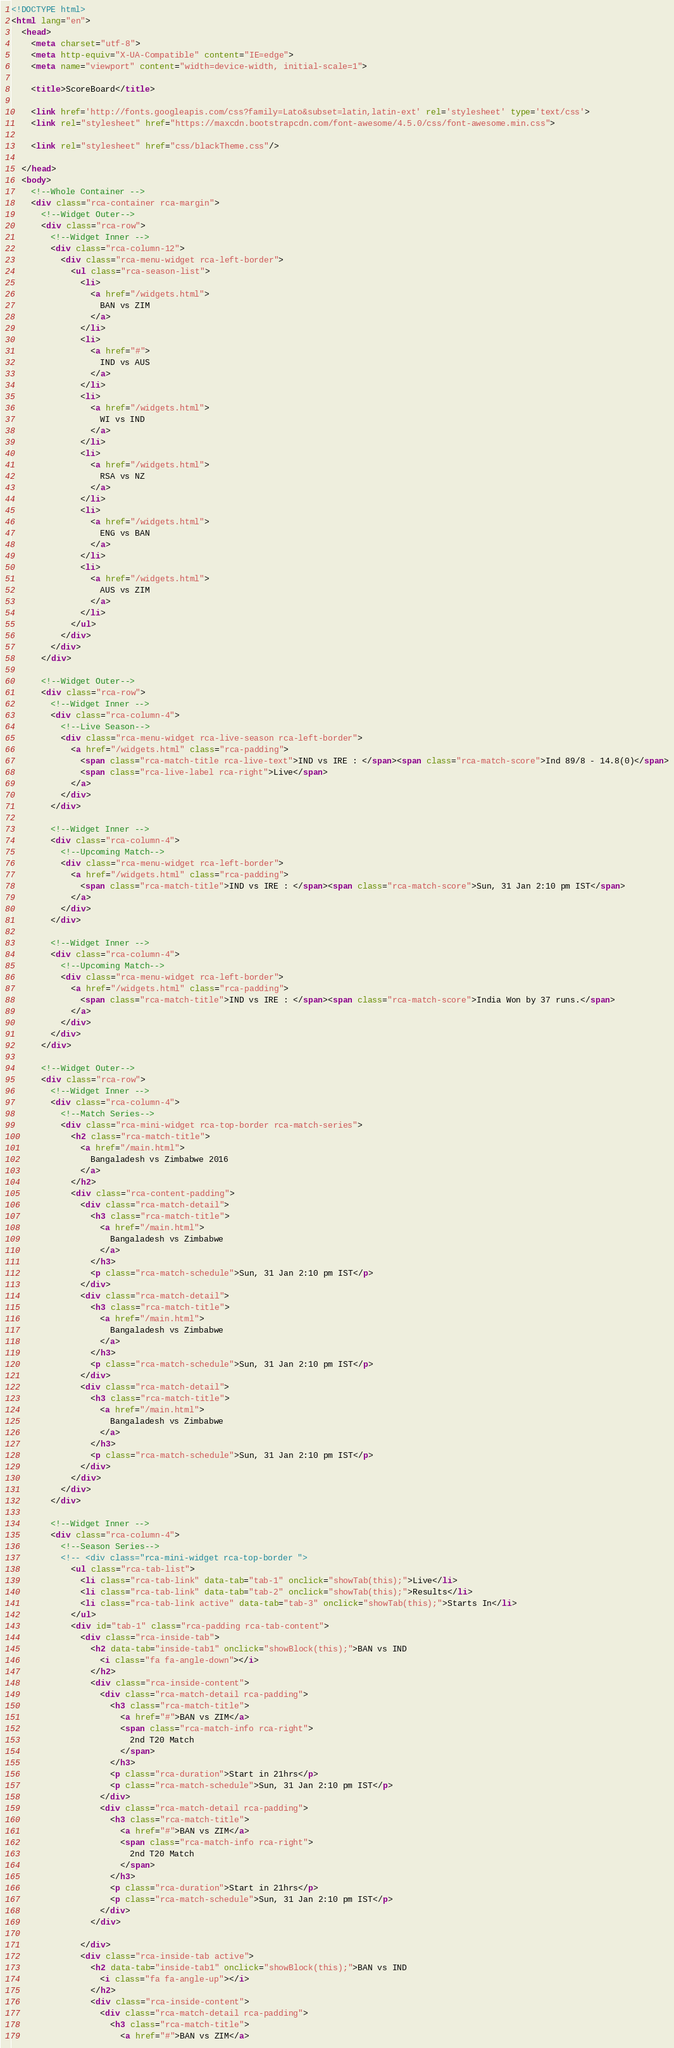<code> <loc_0><loc_0><loc_500><loc_500><_HTML_><!DOCTYPE html>
<html lang="en">
  <head>
    <meta charset="utf-8">
    <meta http-equiv="X-UA-Compatible" content="IE=edge">
    <meta name="viewport" content="width=device-width, initial-scale=1">

    <title>ScoreBoard</title>

    <link href='http://fonts.googleapis.com/css?family=Lato&subset=latin,latin-ext' rel='stylesheet' type='text/css'>
    <link rel="stylesheet" href="https://maxcdn.bootstrapcdn.com/font-awesome/4.5.0/css/font-awesome.min.css">

    <link rel="stylesheet" href="css/blackTheme.css"/>

  </head>
  <body>
    <!--Whole Container -->
    <div class="rca-container rca-margin">
      <!--Widget Outer-->
      <div class="rca-row">
        <!--Widget Inner -->
        <div class="rca-column-12">
          <div class="rca-menu-widget rca-left-border">
            <ul class="rca-season-list">
              <li>
                <a href="/widgets.html">
                  BAN vs ZIM
                </a>
              </li>
              <li>
                <a href="#">
                  IND vs AUS
                </a>
              </li>
              <li>
                <a href="/widgets.html">
                  WI vs IND
                </a>
              </li>
              <li>
                <a href="/widgets.html">
                  RSA vs NZ
                </a>
              </li>
              <li>
                <a href="/widgets.html">
                  ENG vs BAN
                </a>
              </li>
              <li>
                <a href="/widgets.html">
                  AUS vs ZIM
                </a>
              </li>
            </ul>
          </div>
        </div>
      </div>

      <!--Widget Outer-->
      <div class="rca-row">
        <!--Widget Inner -->
        <div class="rca-column-4">
          <!--Live Season-->
          <div class="rca-menu-widget rca-live-season rca-left-border">
            <a href="/widgets.html" class="rca-padding">
              <span class="rca-match-title rca-live-text">IND vs IRE : </span><span class="rca-match-score">Ind 89/8 - 14.8(0)</span>
              <span class="rca-live-label rca-right">Live</span>
            </a>
          </div>
        </div>
        
        <!--Widget Inner -->
        <div class="rca-column-4">
          <!--Upcoming Match-->
          <div class="rca-menu-widget rca-left-border">
            <a href="/widgets.html" class="rca-padding">
              <span class="rca-match-title">IND vs IRE : </span><span class="rca-match-score">Sun, 31 Jan 2:10 pm IST</span>
            </a>
          </div>
        </div>

        <!--Widget Inner -->
        <div class="rca-column-4">
          <!--Upcoming Match-->
          <div class="rca-menu-widget rca-left-border">
            <a href="/widgets.html" class="rca-padding">
              <span class="rca-match-title">IND vs IRE : </span><span class="rca-match-score">India Won by 37 runs.</span>
            </a>
          </div>
        </div>
      </div>

      <!--Widget Outer-->
      <div class="rca-row">
        <!--Widget Inner -->
        <div class="rca-column-4">
          <!--Match Series-->
          <div class="rca-mini-widget rca-top-border rca-match-series">
            <h2 class="rca-match-title">
              <a href="/main.html">
                Bangaladesh vs Zimbabwe 2016
              </a>
            </h2>
            <div class="rca-content-padding">
              <div class="rca-match-detail">
                <h3 class="rca-match-title">
                  <a href="/main.html">
                    Bangaladesh vs Zimbabwe
                  </a>
                </h3>
                <p class="rca-match-schedule">Sun, 31 Jan 2:10 pm IST</p>
              </div>
              <div class="rca-match-detail">
                <h3 class="rca-match-title">
                  <a href="/main.html">
                    Bangaladesh vs Zimbabwe
                  </a>
                </h3>
                <p class="rca-match-schedule">Sun, 31 Jan 2:10 pm IST</p>
              </div>
              <div class="rca-match-detail">
                <h3 class="rca-match-title">
                  <a href="/main.html">
                    Bangaladesh vs Zimbabwe
                  </a>
                </h3>
                <p class="rca-match-schedule">Sun, 31 Jan 2:10 pm IST</p>
              </div>
            </div>
          </div>
        </div>

        <!--Widget Inner -->
        <div class="rca-column-4">
          <!--Season Series-->
          <!-- <div class="rca-mini-widget rca-top-border ">
            <ul class="rca-tab-list">
              <li class="rca-tab-link" data-tab="tab-1" onclick="showTab(this);">Live</li>
              <li class="rca-tab-link" data-tab="tab-2" onclick="showTab(this);">Results</li>
              <li class="rca-tab-link active" data-tab="tab-3" onclick="showTab(this);">Starts In</li>
            </ul>
            <div id="tab-1" class="rca-padding rca-tab-content">
              <div class="rca-inside-tab">
                <h2 data-tab="inside-tab1" onclick="showBlock(this);">BAN vs IND
                  <i class="fa fa-angle-down"></i>
                </h2>
                <div class="rca-inside-content">
                  <div class="rca-match-detail rca-padding">
                    <h3 class="rca-match-title">
                      <a href="#">BAN vs ZIM</a>
                      <span class="rca-match-info rca-right">
                        2nd T20 Match
                      </span>
                    </h3>
                    <p class="rca-duration">Start in 21hrs</p>
                    <p class="rca-match-schedule">Sun, 31 Jan 2:10 pm IST</p>
                  </div>
                  <div class="rca-match-detail rca-padding">
                    <h3 class="rca-match-title">
                      <a href="#">BAN vs ZIM</a>
                      <span class="rca-match-info rca-right">
                        2nd T20 Match
                      </span>
                    </h3>
                    <p class="rca-duration">Start in 21hrs</p>
                    <p class="rca-match-schedule">Sun, 31 Jan 2:10 pm IST</p>
                  </div>
                </div>

              </div>
              <div class="rca-inside-tab active">
                <h2 data-tab="inside-tab1" onclick="showBlock(this);">BAN vs IND
                  <i class="fa fa-angle-up"></i>
                </h2>
                <div class="rca-inside-content">
                  <div class="rca-match-detail rca-padding">
                    <h3 class="rca-match-title">
                      <a href="#">BAN vs ZIM</a></code> 